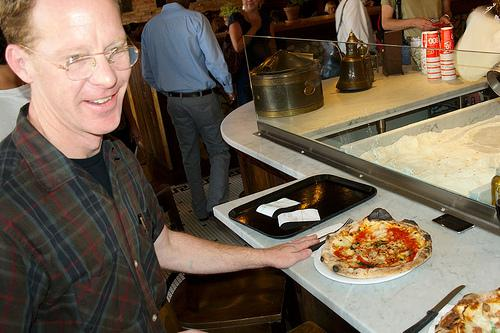Question: where are the receipts?
Choices:
A. On the table.
B. The tray.
C. On the bed.
D. In his hand.
Answer with the letter. Answer: B Question: how many pairs of glasses are shown?
Choices:
A. One.
B. Two.
C. None.
D. Three.
Answer with the letter. Answer: A Question: where are the people?
Choices:
A. In a blizzard.
B. At a commencement ceremony.
C. A restaurant.
D. At home.
Answer with the letter. Answer: C Question: what color is the plate?
Choices:
A. White.
B. Blue.
C. Grey.
D. Black.
Answer with the letter. Answer: A Question: what is on the plate?
Choices:
A. Crumbs.
B. Salad.
C. Pizza.
D. Cake.
Answer with the letter. Answer: C 